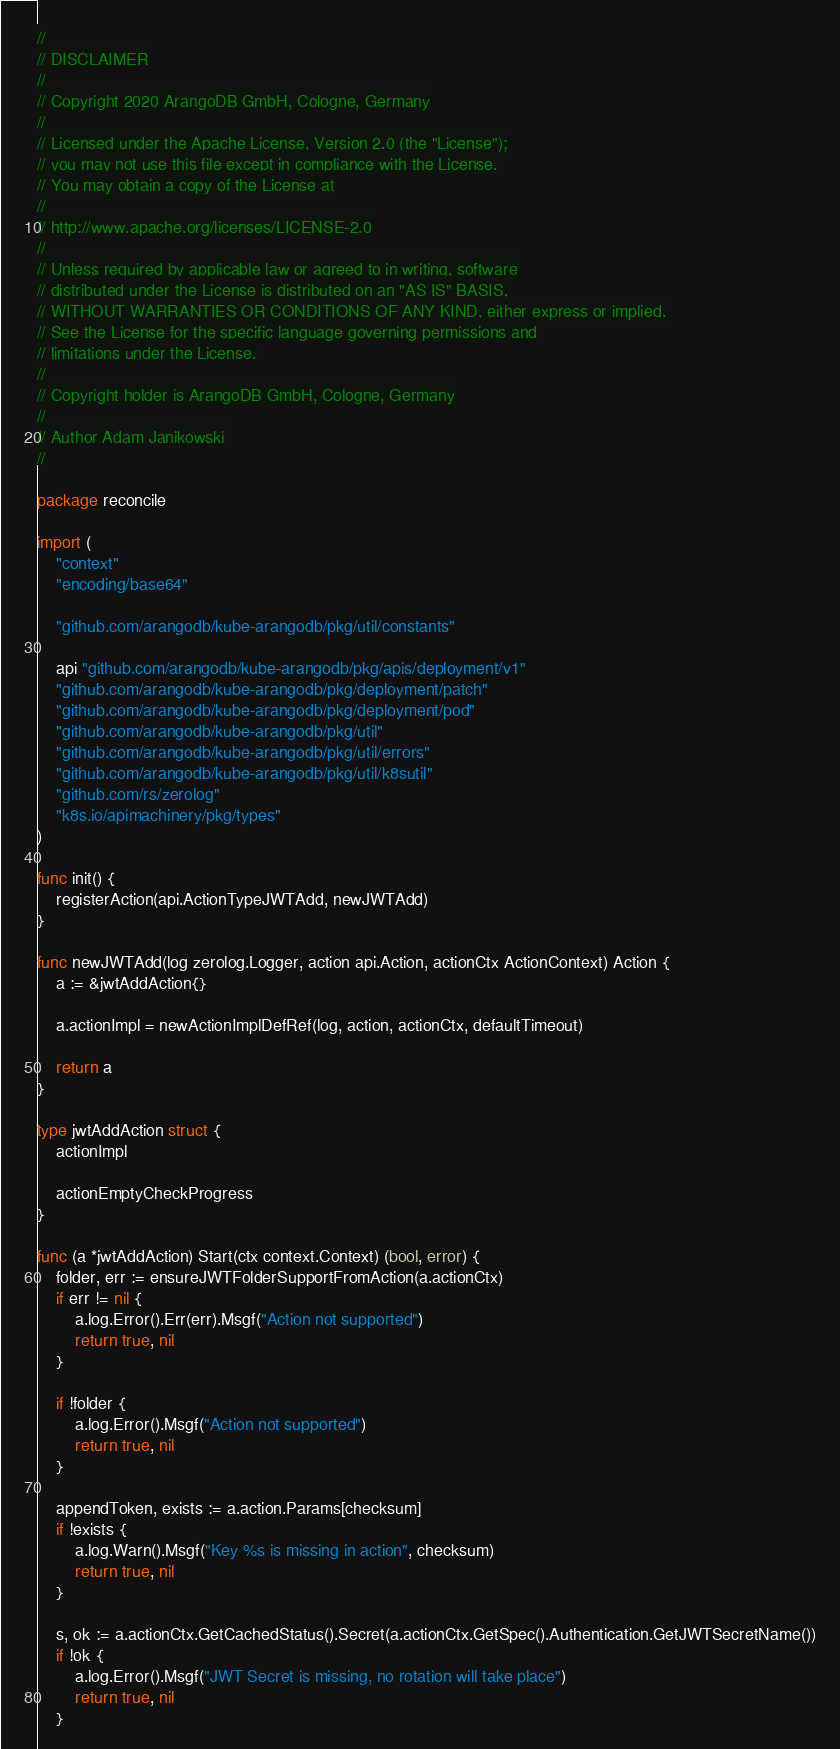Convert code to text. <code><loc_0><loc_0><loc_500><loc_500><_Go_>//
// DISCLAIMER
//
// Copyright 2020 ArangoDB GmbH, Cologne, Germany
//
// Licensed under the Apache License, Version 2.0 (the "License");
// you may not use this file except in compliance with the License.
// You may obtain a copy of the License at
//
// http://www.apache.org/licenses/LICENSE-2.0
//
// Unless required by applicable law or agreed to in writing, software
// distributed under the License is distributed on an "AS IS" BASIS,
// WITHOUT WARRANTIES OR CONDITIONS OF ANY KIND, either express or implied.
// See the License for the specific language governing permissions and
// limitations under the License.
//
// Copyright holder is ArangoDB GmbH, Cologne, Germany
//
// Author Adam Janikowski
//

package reconcile

import (
	"context"
	"encoding/base64"

	"github.com/arangodb/kube-arangodb/pkg/util/constants"

	api "github.com/arangodb/kube-arangodb/pkg/apis/deployment/v1"
	"github.com/arangodb/kube-arangodb/pkg/deployment/patch"
	"github.com/arangodb/kube-arangodb/pkg/deployment/pod"
	"github.com/arangodb/kube-arangodb/pkg/util"
	"github.com/arangodb/kube-arangodb/pkg/util/errors"
	"github.com/arangodb/kube-arangodb/pkg/util/k8sutil"
	"github.com/rs/zerolog"
	"k8s.io/apimachinery/pkg/types"
)

func init() {
	registerAction(api.ActionTypeJWTAdd, newJWTAdd)
}

func newJWTAdd(log zerolog.Logger, action api.Action, actionCtx ActionContext) Action {
	a := &jwtAddAction{}

	a.actionImpl = newActionImplDefRef(log, action, actionCtx, defaultTimeout)

	return a
}

type jwtAddAction struct {
	actionImpl

	actionEmptyCheckProgress
}

func (a *jwtAddAction) Start(ctx context.Context) (bool, error) {
	folder, err := ensureJWTFolderSupportFromAction(a.actionCtx)
	if err != nil {
		a.log.Error().Err(err).Msgf("Action not supported")
		return true, nil
	}

	if !folder {
		a.log.Error().Msgf("Action not supported")
		return true, nil
	}

	appendToken, exists := a.action.Params[checksum]
	if !exists {
		a.log.Warn().Msgf("Key %s is missing in action", checksum)
		return true, nil
	}

	s, ok := a.actionCtx.GetCachedStatus().Secret(a.actionCtx.GetSpec().Authentication.GetJWTSecretName())
	if !ok {
		a.log.Error().Msgf("JWT Secret is missing, no rotation will take place")
		return true, nil
	}
</code> 